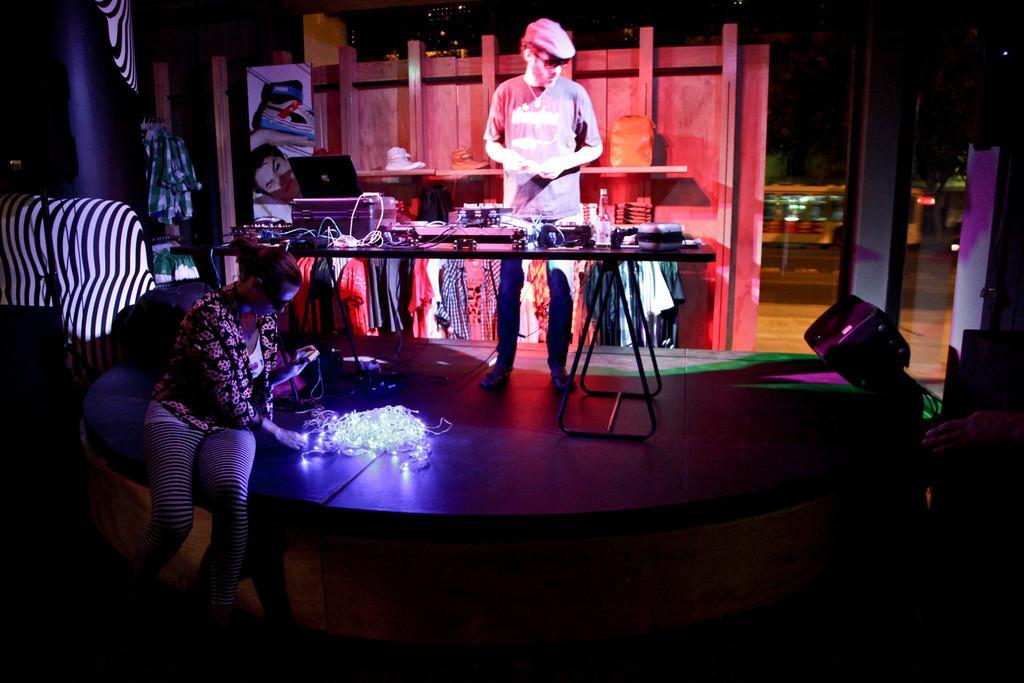Can you describe this image briefly? In this image we can see two people and there is a stage with lights and we can see a table in front of a person and on the table, we can see a laptop, bottle and some other things. In the background, there is a rack with clothes, shoes and some other objects. There is a vehicle on the road. 